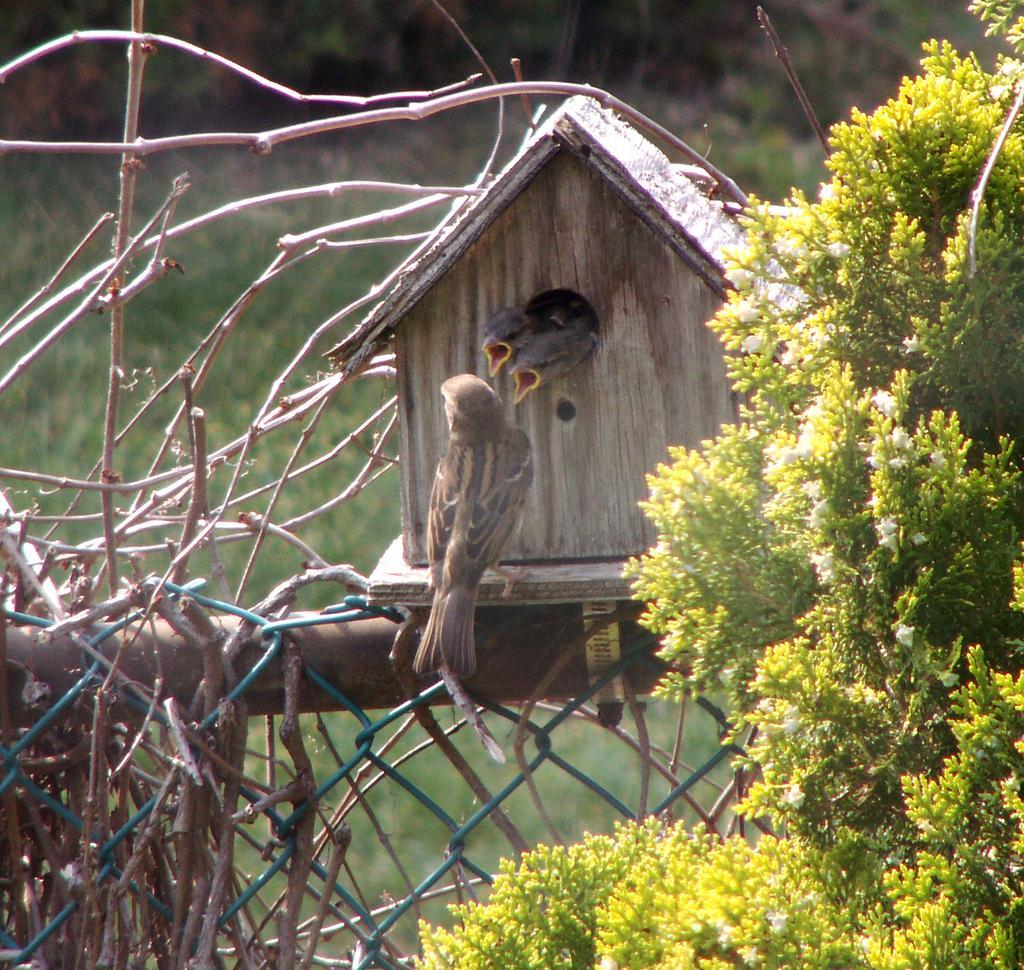How would you summarize this image in a sentence or two? Here we can see a bird standing on a platform at the bird house and we can see two more birds. On the right there is a plant and on the left there is a net,pole. In the background we can see grass. 